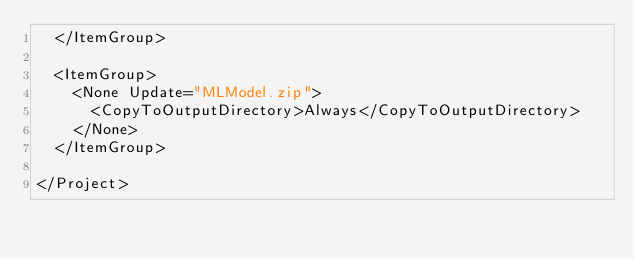<code> <loc_0><loc_0><loc_500><loc_500><_XML_>  </ItemGroup>

  <ItemGroup>
    <None Update="MLModel.zip">
      <CopyToOutputDirectory>Always</CopyToOutputDirectory>
    </None>
  </ItemGroup>
  
</Project>
</code> 